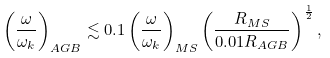<formula> <loc_0><loc_0><loc_500><loc_500>\left ( \frac { \omega } { \omega _ { k } } \right ) _ { A G B } \lesssim 0 . 1 \left ( \frac { \omega } { \omega _ { k } } \right ) _ { M S } \left ( \frac { R _ { M S } } { 0 . 0 1 R _ { A G B } } \right ) ^ { \frac { 1 } { 2 } } ,</formula> 